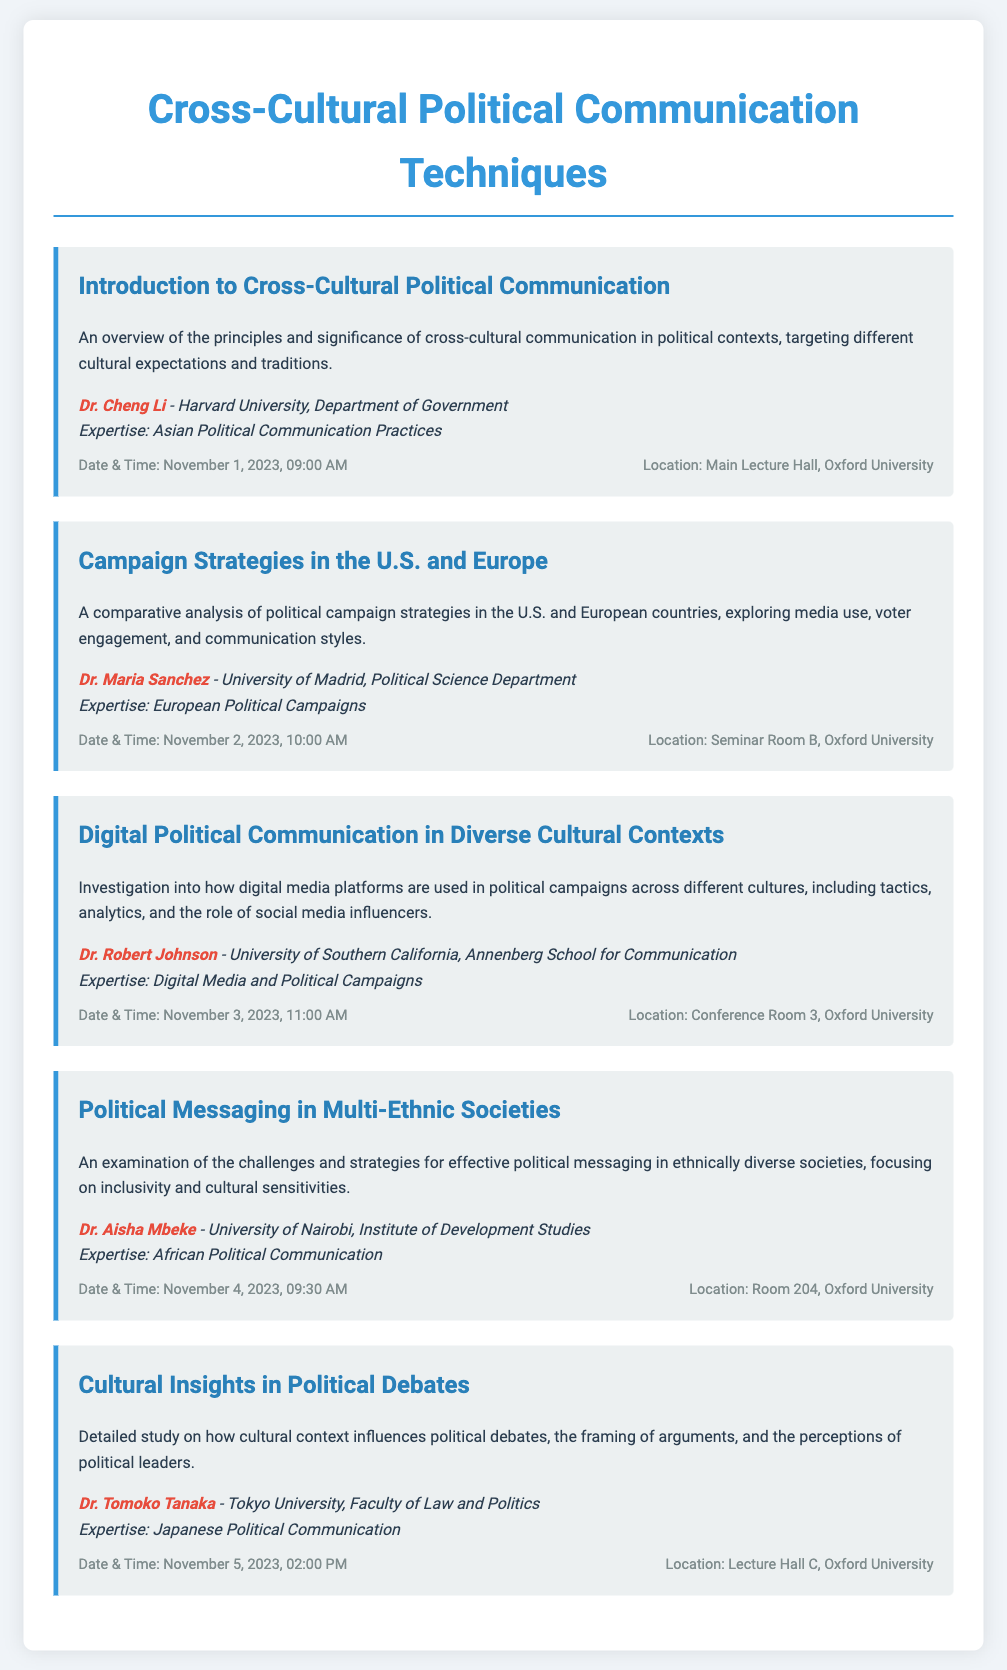what is the title of the workshop series? The title of the workshop series is stated at the top of the document.
Answer: Cross-Cultural Political Communication Techniques who is the speaker for the session on Digital Political Communication? The speaker for the session can be found with information related to the session and is highlighted in the document.
Answer: Dr. Robert Johnson what date and time is the session on Political Messaging in Multi-Ethnic Societies? The session details including date and time are provided within the session information.
Answer: November 4, 2023, 09:30 AM which university is Dr. Aisha Mbeke associated with? The affiliation of Dr. Aisha Mbeke is given in the speaker section of the session.
Answer: University of Nairobi what is the location of the Introduction to Cross-Cultural Political Communication session? The location is specified in the session information section of the document.
Answer: Main Lecture Hall, Oxford University which session is scheduled for November 2, 2023? The date and title of sessions are listed, allowing for the identification of sessions by date.
Answer: Campaign Strategies in the U.S. and Europe who is the speaker of the first session? The speaker information is presented alongside each session, making it easy to find.
Answer: Dr. Cheng Li what is the common theme of all sessions in the workshop series? The overarching topic can be inferred by looking at the titles and descriptions of individual sessions.
Answer: Cross-Cultural Political Communication Techniques 